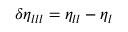Convert formula to latex. <formula><loc_0><loc_0><loc_500><loc_500>\delta \eta _ { l l l } = \eta _ { l l } - \eta _ { l }</formula> 